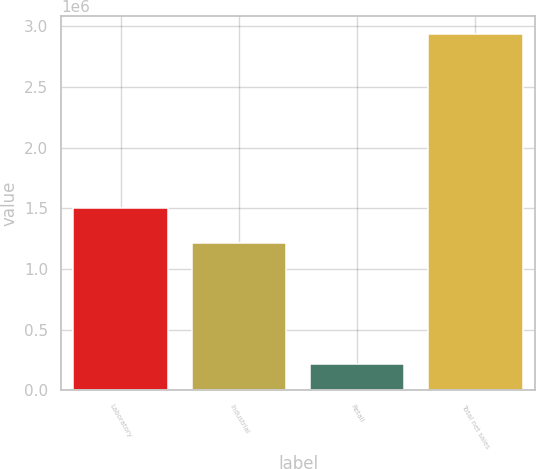<chart> <loc_0><loc_0><loc_500><loc_500><bar_chart><fcel>Laboratory<fcel>Industrial<fcel>Retail<fcel>Total net sales<nl><fcel>1.5046e+06<fcel>1.21136e+06<fcel>219624<fcel>2.93559e+06<nl></chart> 